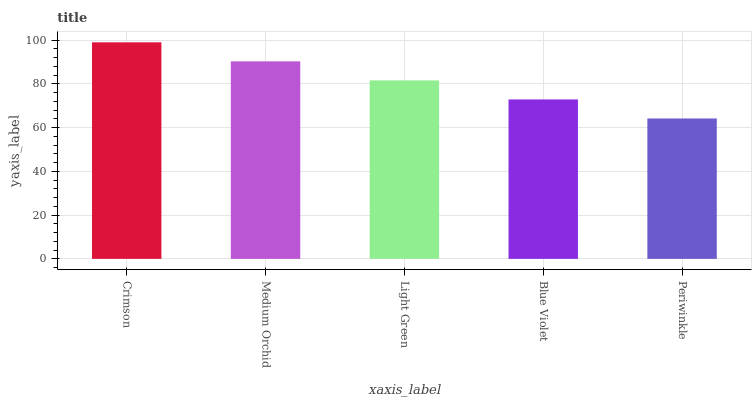Is Periwinkle the minimum?
Answer yes or no. Yes. Is Crimson the maximum?
Answer yes or no. Yes. Is Medium Orchid the minimum?
Answer yes or no. No. Is Medium Orchid the maximum?
Answer yes or no. No. Is Crimson greater than Medium Orchid?
Answer yes or no. Yes. Is Medium Orchid less than Crimson?
Answer yes or no. Yes. Is Medium Orchid greater than Crimson?
Answer yes or no. No. Is Crimson less than Medium Orchid?
Answer yes or no. No. Is Light Green the high median?
Answer yes or no. Yes. Is Light Green the low median?
Answer yes or no. Yes. Is Blue Violet the high median?
Answer yes or no. No. Is Medium Orchid the low median?
Answer yes or no. No. 